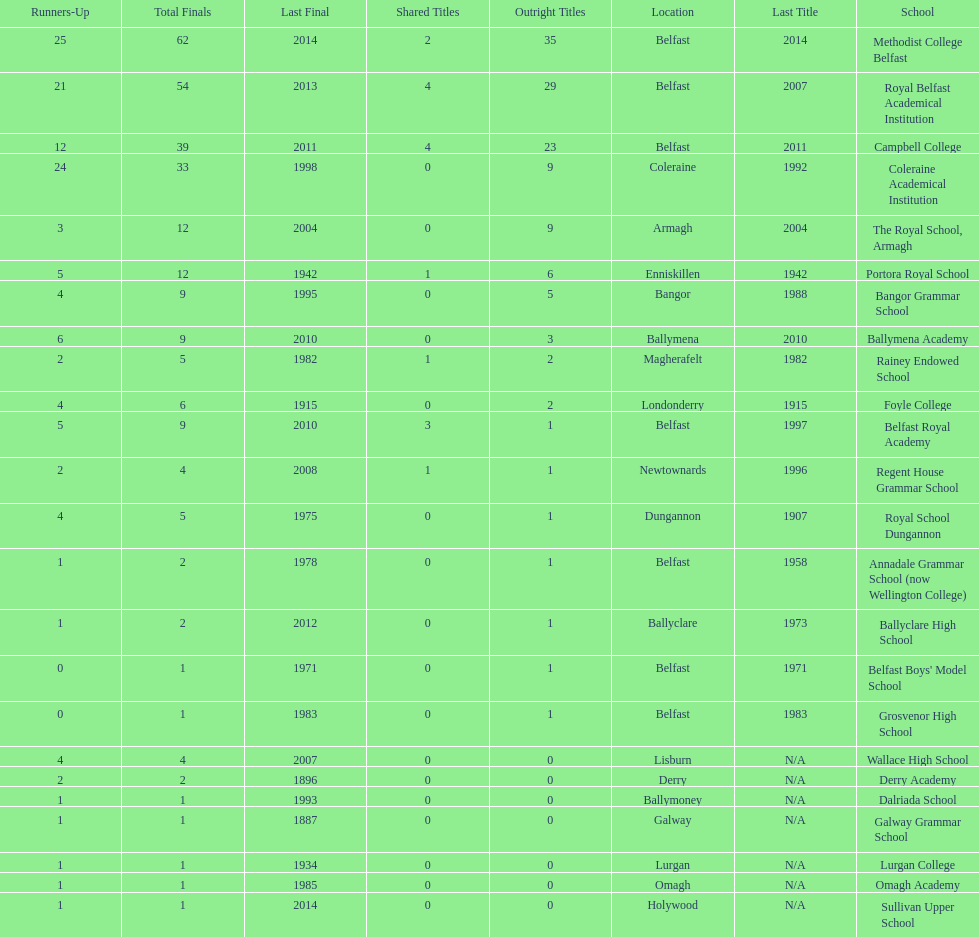What number of total finals does foyle college have? 6. 